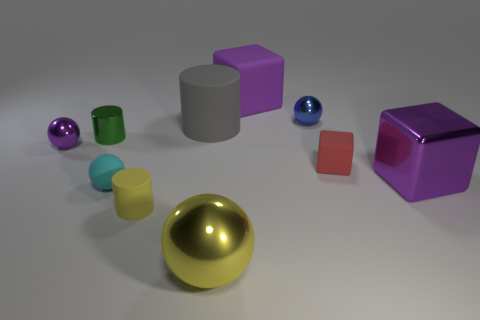There is a big gray matte object; are there any balls behind it?
Provide a short and direct response. Yes. There is a purple object that is behind the gray rubber cylinder; what number of large blocks are on the right side of it?
Keep it short and to the point. 1. There is a gray thing that is the same size as the yellow ball; what material is it?
Ensure brevity in your answer.  Rubber. How many other objects are the same material as the cyan thing?
Offer a terse response. 4. What number of metallic things are behind the big cylinder?
Offer a very short reply. 1. How many cubes are gray matte objects or small red rubber things?
Your response must be concise. 1. How big is the thing that is in front of the purple matte cube and behind the big gray thing?
Keep it short and to the point. Small. What number of other things are there of the same color as the tiny rubber cylinder?
Make the answer very short. 1. Do the gray thing and the small sphere in front of the big metal cube have the same material?
Provide a succinct answer. Yes. What number of things are either rubber objects that are in front of the small cyan rubber thing or yellow metallic balls?
Your response must be concise. 2. 